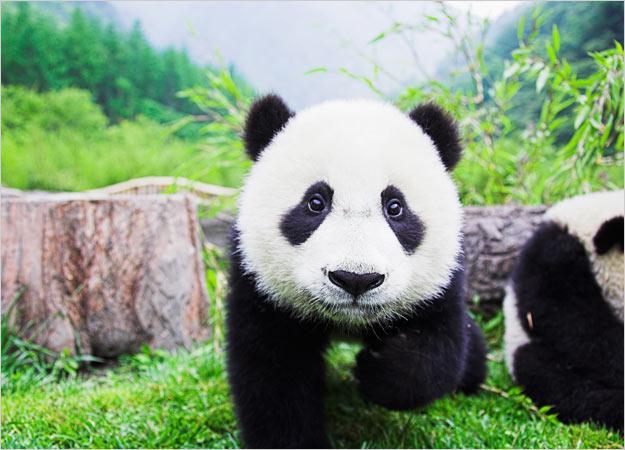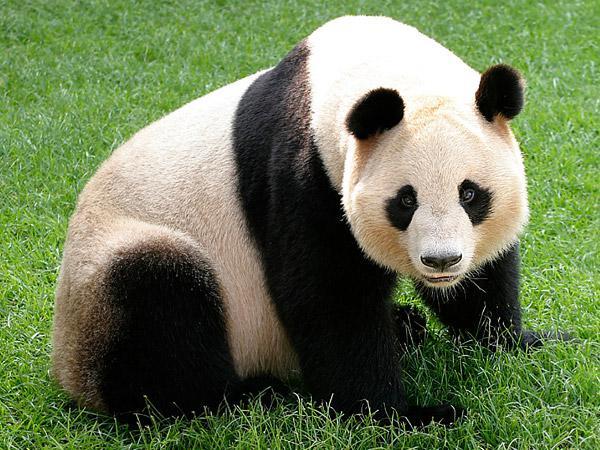The first image is the image on the left, the second image is the image on the right. Analyze the images presented: Is the assertion "the panda on the left image has its mouth open" valid? Answer yes or no. No. 